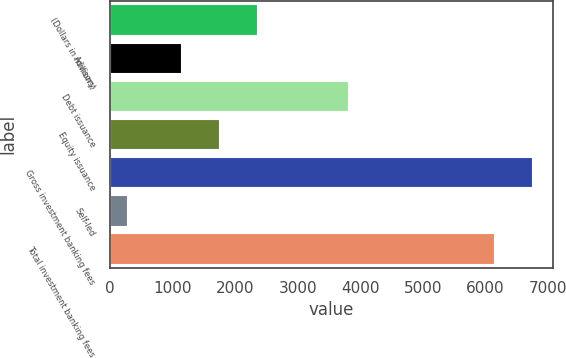Convert chart to OTSL. <chart><loc_0><loc_0><loc_500><loc_500><bar_chart><fcel>(Dollars in millions)<fcel>Advisory<fcel>Debt issuance<fcel>Equity issuance<fcel>Gross investment banking fees<fcel>Self-led<fcel>Total investment banking fees<nl><fcel>2356.2<fcel>1131<fcel>3805<fcel>1743.6<fcel>6738.6<fcel>279<fcel>6126<nl></chart> 